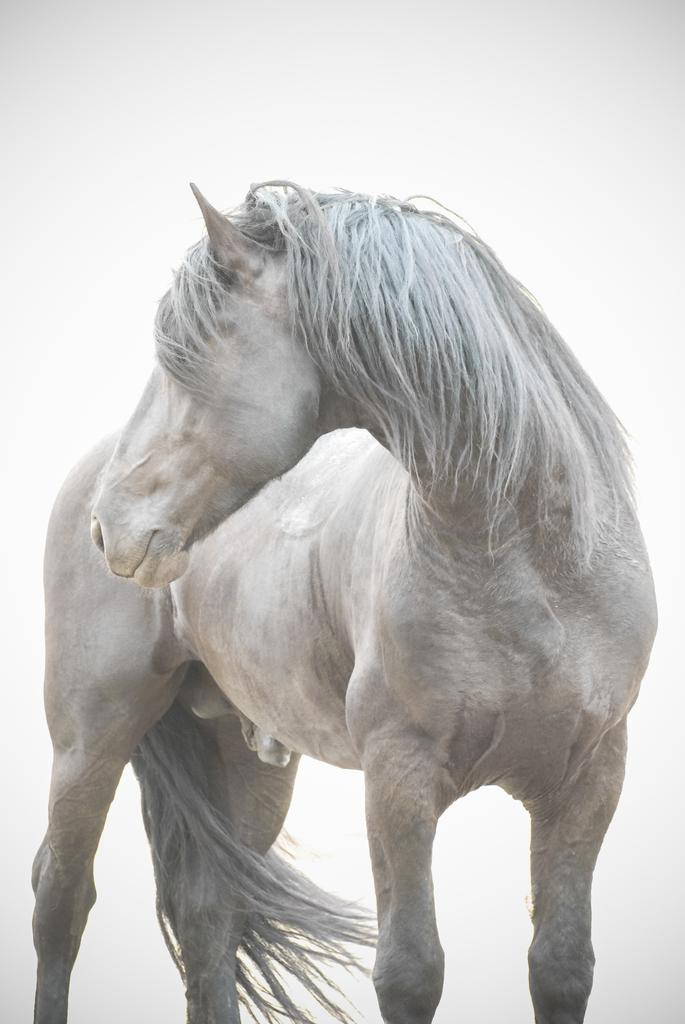What animal is present in the image? There is a horse in the image. What is the color of the horse? The horse is white in color. How is the horse positioned in the image? The horse is in a standing position. What can be seen in the background of the image? There is sky visible in the background of the image. What type of flower is the horse holding in its mouth in the image? There is no flower present in the image, and the horse is not holding anything in its mouth. 